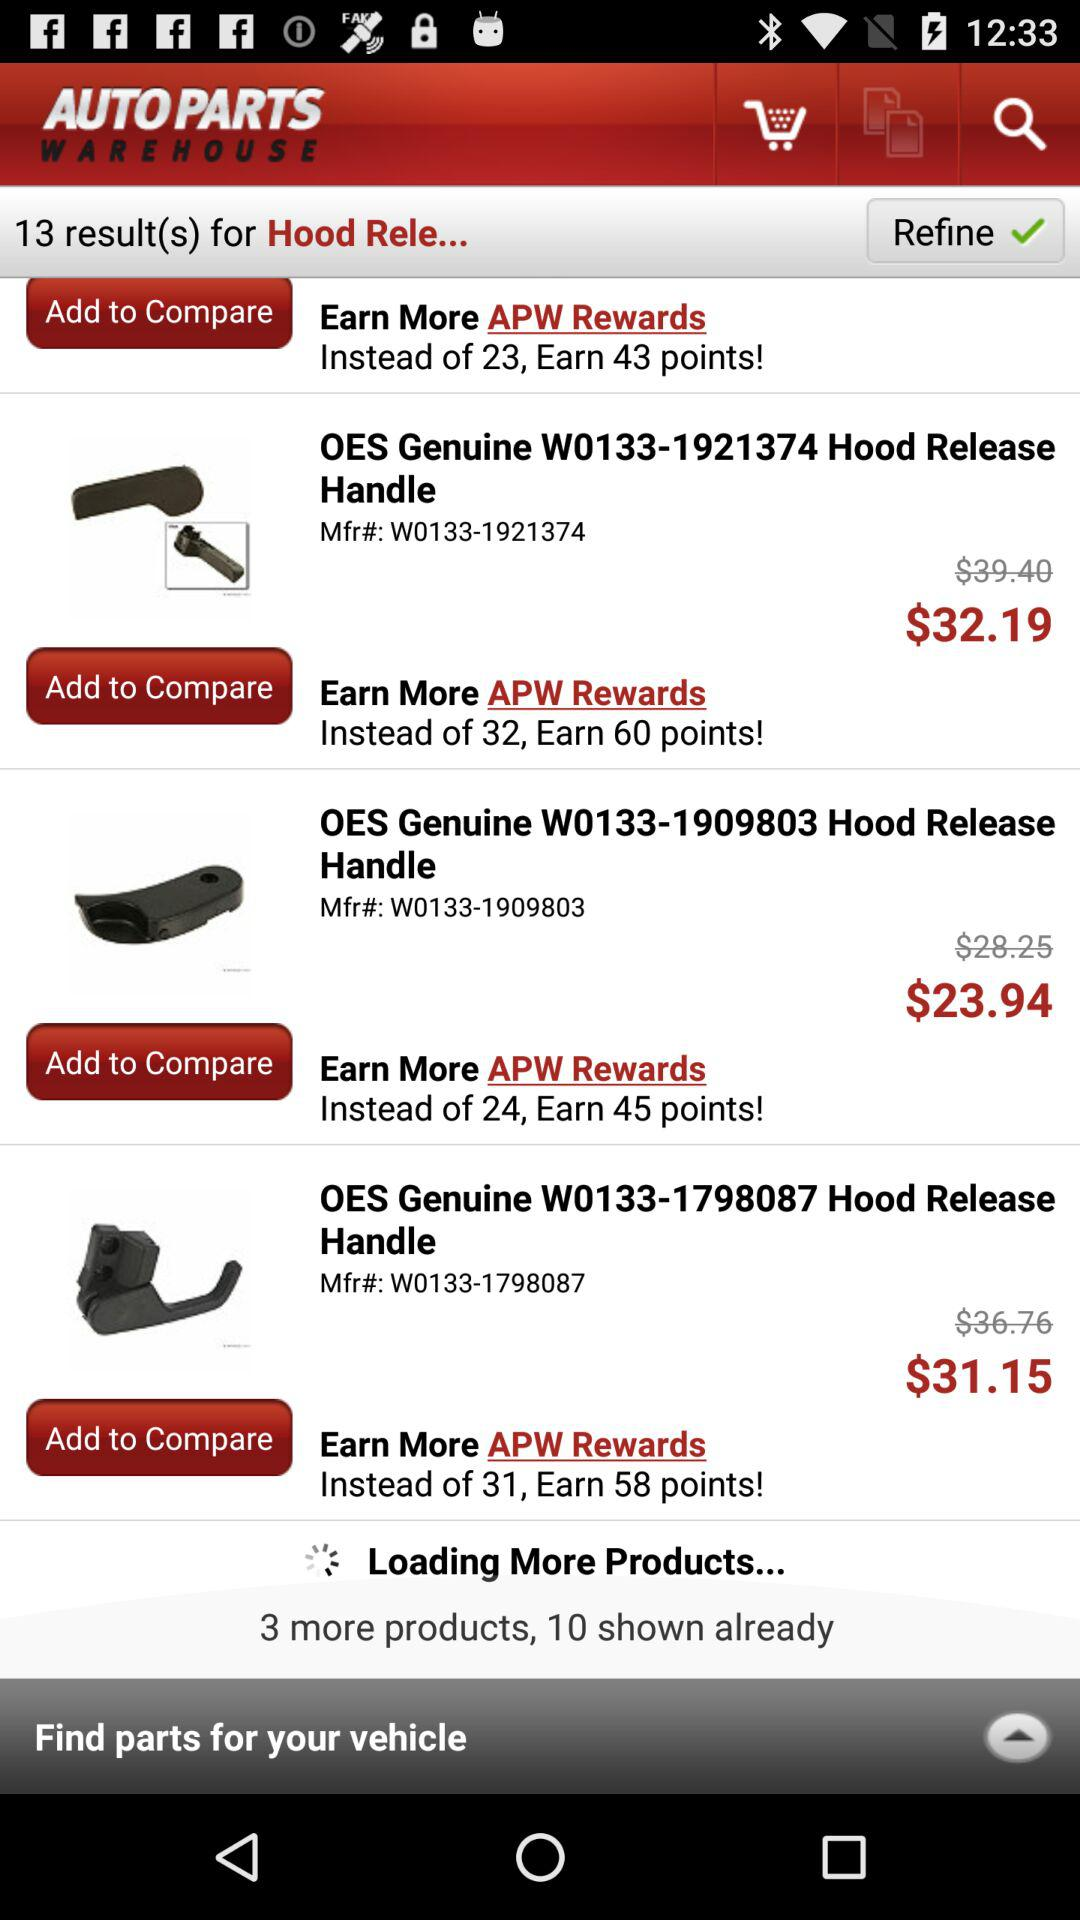How many more products are there? There are 3 more products. 